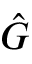<formula> <loc_0><loc_0><loc_500><loc_500>\hat { G }</formula> 